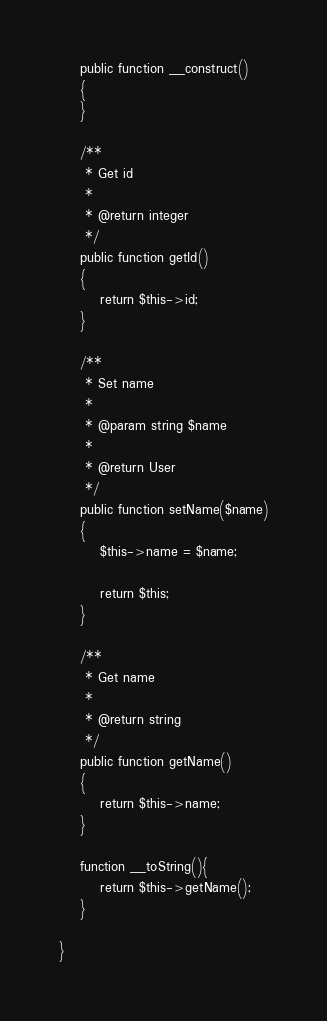Convert code to text. <code><loc_0><loc_0><loc_500><loc_500><_PHP_>
    public function __construct()
    {
    }

    /**
     * Get id
     *
     * @return integer
     */
    public function getId()
    {
        return $this->id;
    }

    /**
     * Set name
     *
     * @param string $name
     *
     * @return User
     */
    public function setName($name)
    {
        $this->name = $name;

        return $this;
    }

    /**
     * Get name
     *
     * @return string
     */
    public function getName()
    {
        return $this->name;
    }

    function __toString(){
        return $this->getName();
    }

}
</code> 